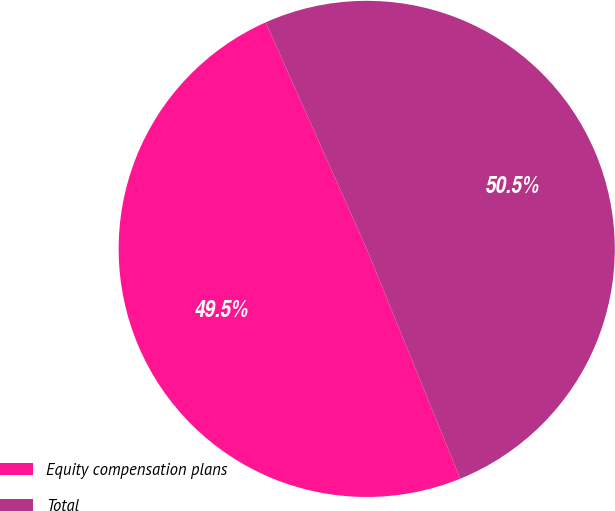Convert chart to OTSL. <chart><loc_0><loc_0><loc_500><loc_500><pie_chart><fcel>Equity compensation plans<fcel>Total<nl><fcel>49.48%<fcel>50.52%<nl></chart> 